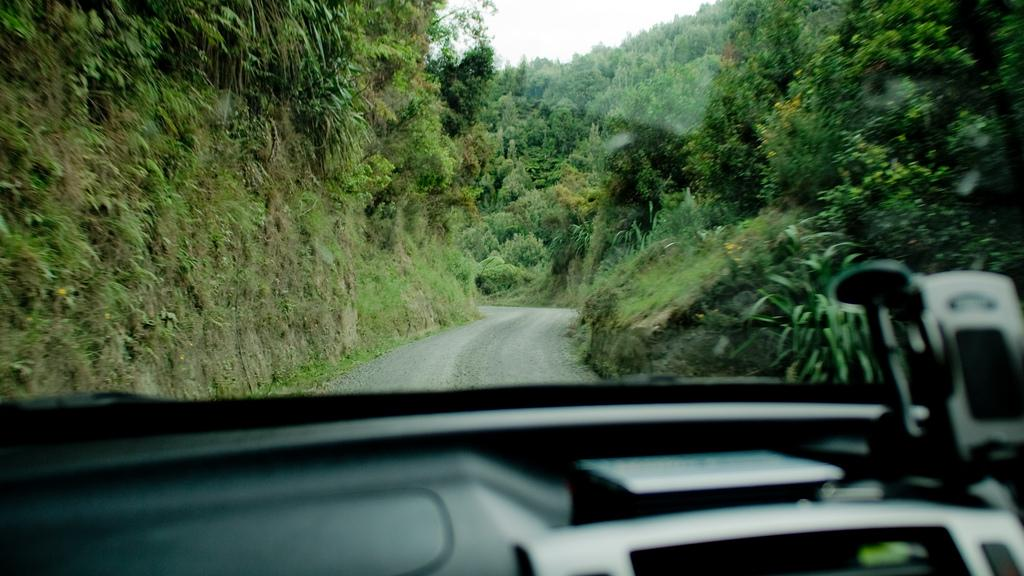What type of natural elements can be seen in the image? There are many trees and plants in the image. What type of man-made structure is present in the image? There is a road in the image. What is the setting of the image? The setting of the image is inside a vehicle. What type of linen is used to cover the seats in the vehicle? There is no information about the type of linen used to cover the seats in the vehicle, as the image does not provide such details. 